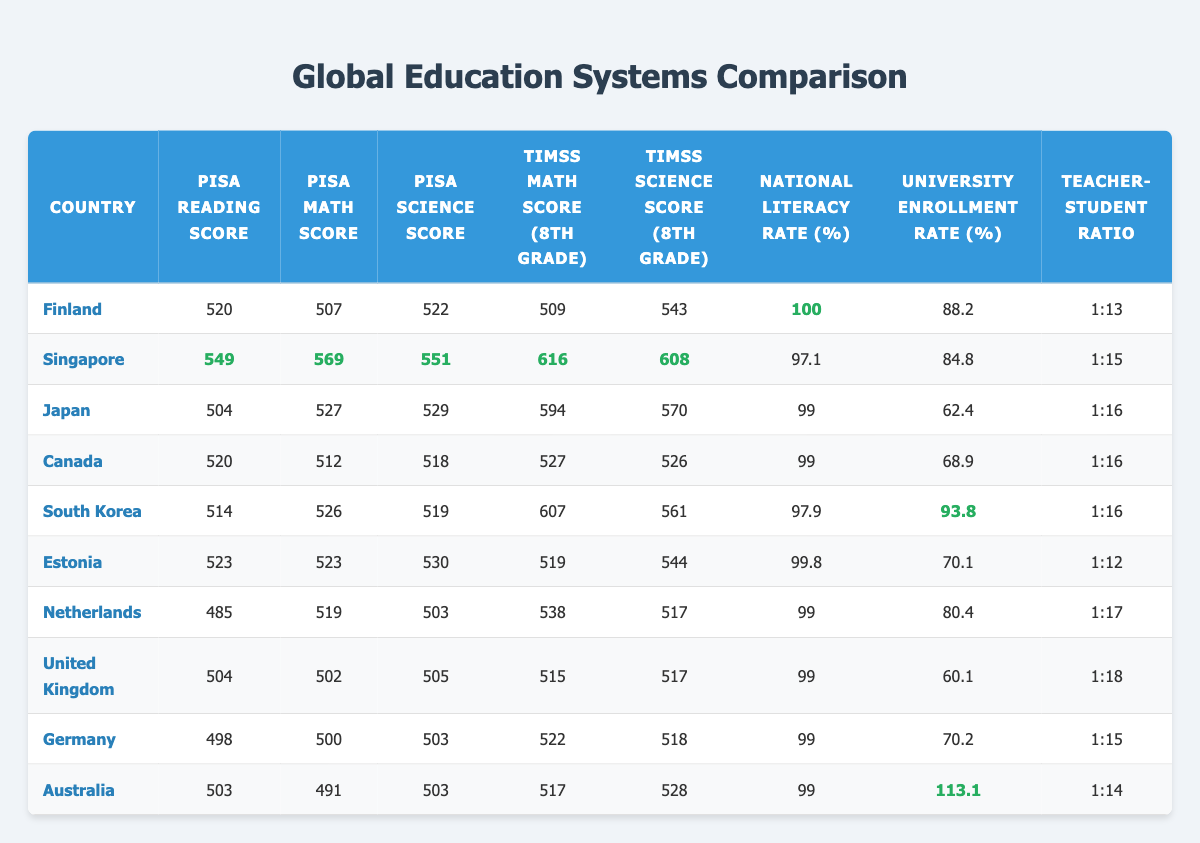What is the PISA Reading Score of Singapore? The PISA Reading Score for Singapore is listed directly in the table under the "PISA Reading Score" column. The value next to Singapore is 549.
Answer: 549 Which country has the highest TIMSS Math Score for 8th grade? To find the highest TIMSS Math Score among the countries, you compare the values in the "TIMSS Math Score (8th grade)" column. The highest score is 616 from Singapore.
Answer: Singapore Is the National Literacy Rate in Australia 100%? The National Literacy Rate for Australia, as indicated in the table, is 99%, which is not equal to 100%. Thus, the statement is false.
Answer: No What is the average PISA Science Score of the countries listed? To calculate the average, sum the PISA Science Scores for each country, which are: 522 (Finland) + 551 (Singapore) + 529 (Japan) + 518 (Canada) + 519 (South Korea) + 530 (Estonia) + 503 (Netherlands) + 505 (United Kingdom) + 503 (Germany) + 503 (Australia) = 5,333. Then, divide by the number of countries (10), giving an average of 533.3.
Answer: 533.3 Which country has the lowest PISA Math Score? The PISA Math Scores are listed in the table, and upon review, the lowest score is 491, which belongs to Australia.
Answer: Australia What is the difference in University Enrollment Rates between Finland and South Korea? The University Enrollment Rate for Finland is 88.2% and for South Korea, it is 93.8%. To find the difference, subtract Finland's rate from South Korea's: 93.8 - 88.2 = 5.6%.
Answer: 5.6% Can a teacher in Japan handle more students than a teacher in Estonia? The teacher-student ratio in Japan is 1:16, while in Estonia it is 1:12. Since 1:16 means more students per teacher, this statement is true.
Answer: Yes What is the combined National Literacy Rate of Germany and the Netherlands? Germany has a National Literacy Rate of 99%, and the Netherlands has a rate of 99%. Summing them: 99 + 99 = 198%.
Answer: 198% 